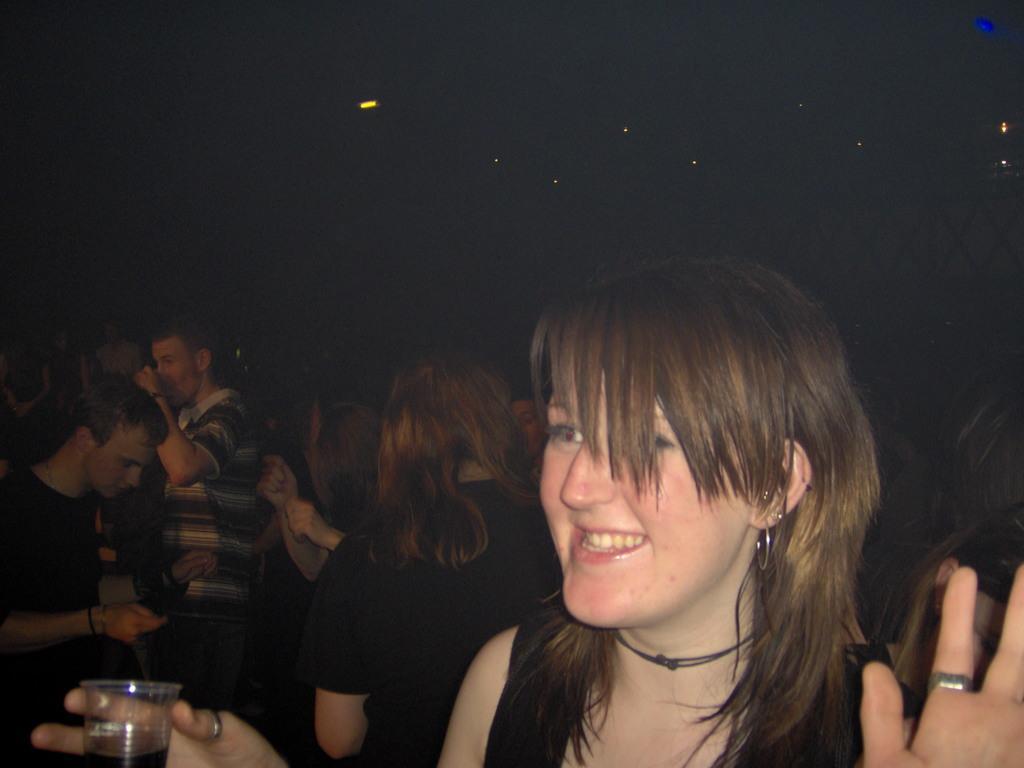In one or two sentences, can you explain what this image depicts? In this image we can see a group of people standing. One woman with long hair is wearing black dress is holding a glass in her hand. To the left side of the image we can person is wearing a black t shirt. In the background, we can see some lights. 